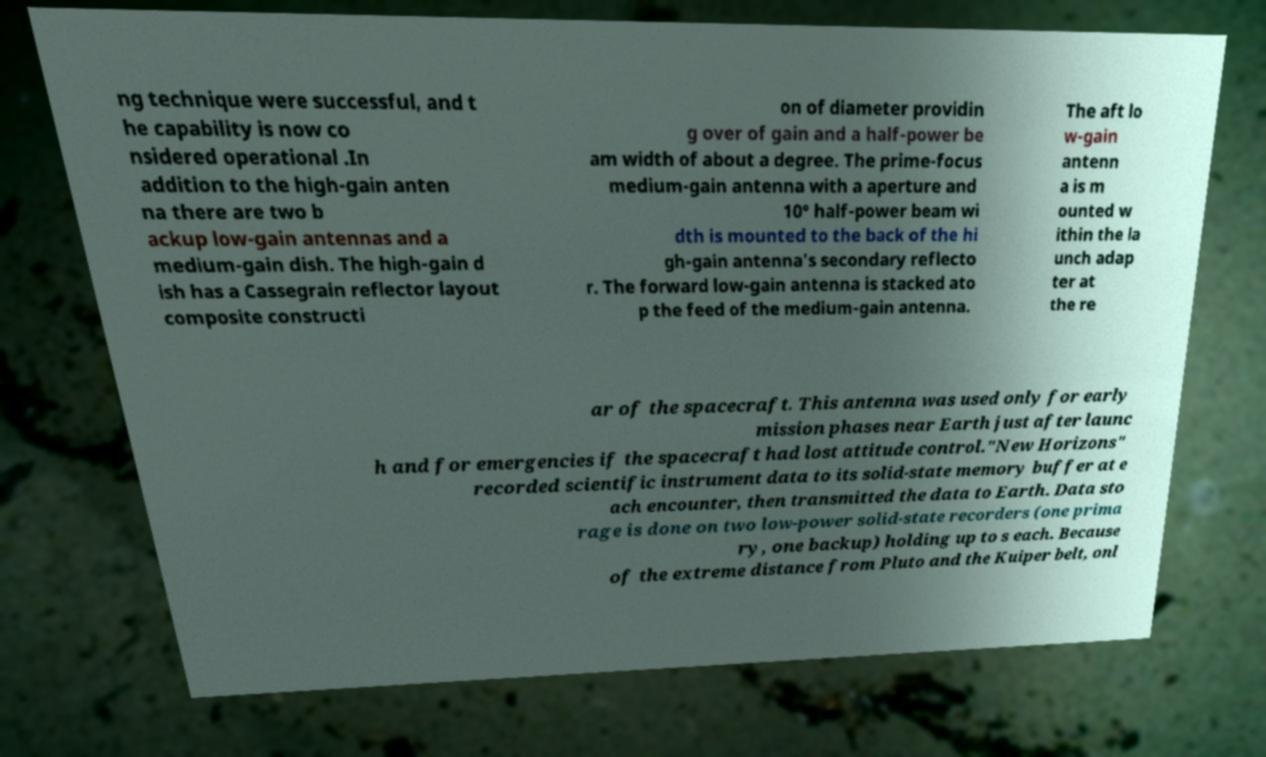I need the written content from this picture converted into text. Can you do that? ng technique were successful, and t he capability is now co nsidered operational .In addition to the high-gain anten na there are two b ackup low-gain antennas and a medium-gain dish. The high-gain d ish has a Cassegrain reflector layout composite constructi on of diameter providin g over of gain and a half-power be am width of about a degree. The prime-focus medium-gain antenna with a aperture and 10° half-power beam wi dth is mounted to the back of the hi gh-gain antenna's secondary reflecto r. The forward low-gain antenna is stacked ato p the feed of the medium-gain antenna. The aft lo w-gain antenn a is m ounted w ithin the la unch adap ter at the re ar of the spacecraft. This antenna was used only for early mission phases near Earth just after launc h and for emergencies if the spacecraft had lost attitude control."New Horizons" recorded scientific instrument data to its solid-state memory buffer at e ach encounter, then transmitted the data to Earth. Data sto rage is done on two low-power solid-state recorders (one prima ry, one backup) holding up to s each. Because of the extreme distance from Pluto and the Kuiper belt, onl 